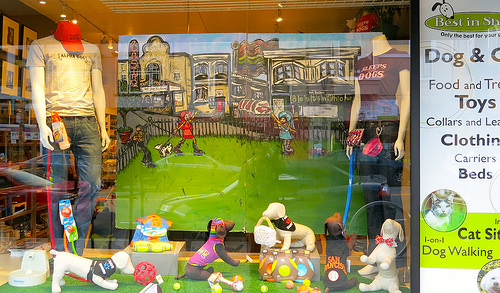<image>
Can you confirm if the shirt is next to the painting? Yes. The shirt is positioned adjacent to the painting, located nearby in the same general area. 